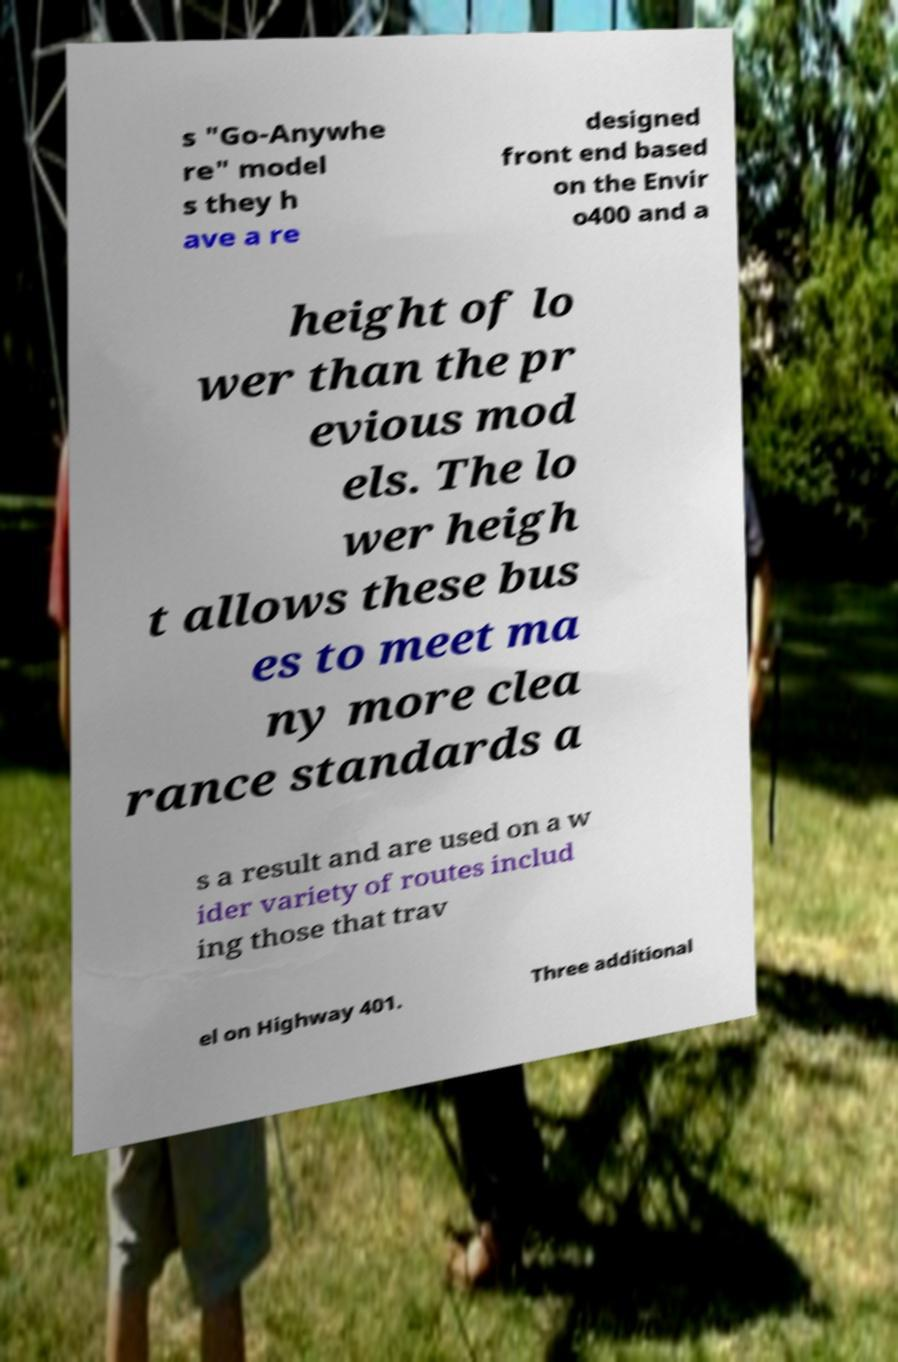Please identify and transcribe the text found in this image. s "Go-Anywhe re" model s they h ave a re designed front end based on the Envir o400 and a height of lo wer than the pr evious mod els. The lo wer heigh t allows these bus es to meet ma ny more clea rance standards a s a result and are used on a w ider variety of routes includ ing those that trav el on Highway 401. Three additional 